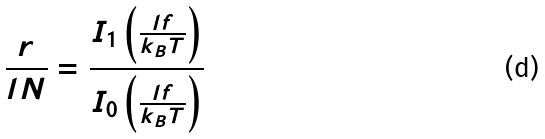<formula> <loc_0><loc_0><loc_500><loc_500>\frac { r } { l N } = \frac { I _ { 1 } \left ( \frac { l f } { k _ { B } T } \right ) } { I _ { 0 } \left ( \frac { l f } { k _ { B } T } \right ) }</formula> 